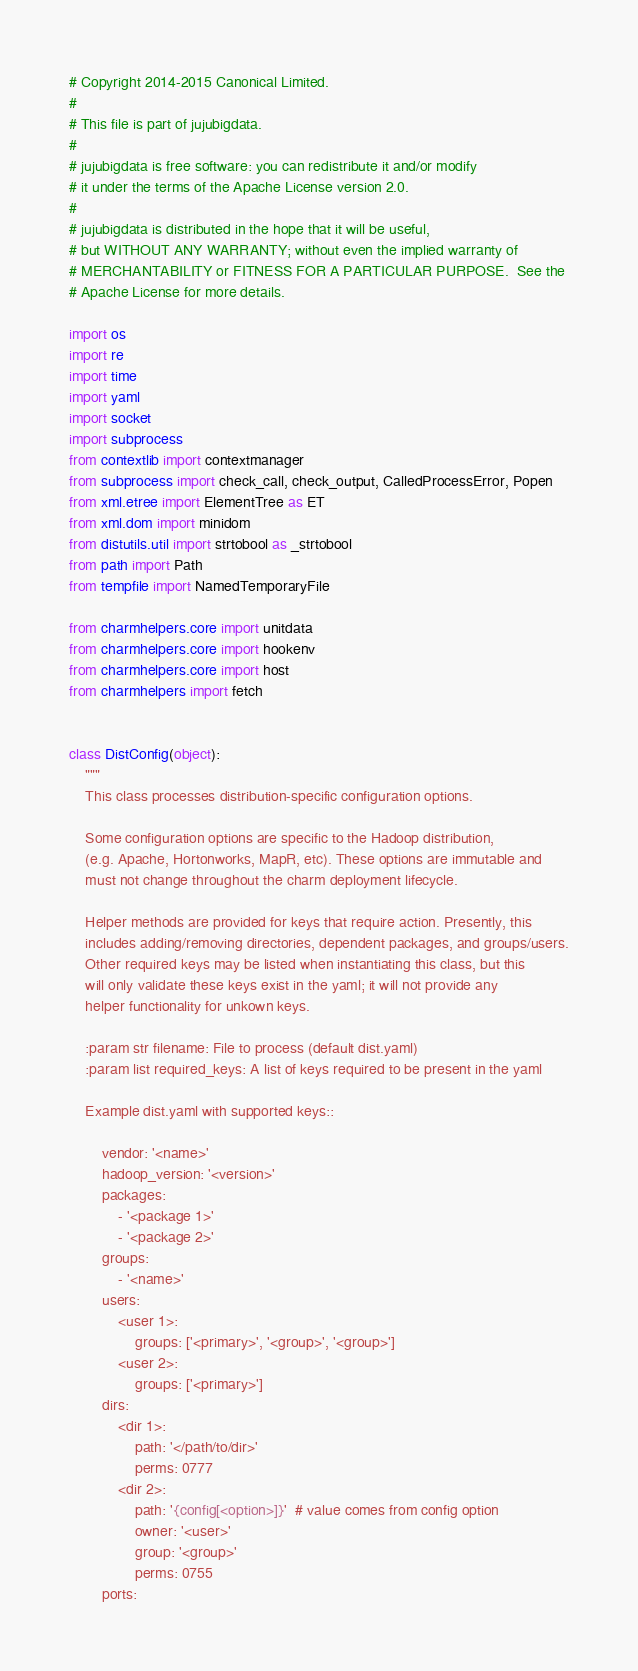Convert code to text. <code><loc_0><loc_0><loc_500><loc_500><_Python_># Copyright 2014-2015 Canonical Limited.
#
# This file is part of jujubigdata.
#
# jujubigdata is free software: you can redistribute it and/or modify
# it under the terms of the Apache License version 2.0.
#
# jujubigdata is distributed in the hope that it will be useful,
# but WITHOUT ANY WARRANTY; without even the implied warranty of
# MERCHANTABILITY or FITNESS FOR A PARTICULAR PURPOSE.  See the
# Apache License for more details.

import os
import re
import time
import yaml
import socket
import subprocess
from contextlib import contextmanager
from subprocess import check_call, check_output, CalledProcessError, Popen
from xml.etree import ElementTree as ET
from xml.dom import minidom
from distutils.util import strtobool as _strtobool
from path import Path
from tempfile import NamedTemporaryFile

from charmhelpers.core import unitdata
from charmhelpers.core import hookenv
from charmhelpers.core import host
from charmhelpers import fetch


class DistConfig(object):
    """
    This class processes distribution-specific configuration options.

    Some configuration options are specific to the Hadoop distribution,
    (e.g. Apache, Hortonworks, MapR, etc). These options are immutable and
    must not change throughout the charm deployment lifecycle.

    Helper methods are provided for keys that require action. Presently, this
    includes adding/removing directories, dependent packages, and groups/users.
    Other required keys may be listed when instantiating this class, but this
    will only validate these keys exist in the yaml; it will not provide any
    helper functionality for unkown keys.

    :param str filename: File to process (default dist.yaml)
    :param list required_keys: A list of keys required to be present in the yaml

    Example dist.yaml with supported keys::

        vendor: '<name>'
        hadoop_version: '<version>'
        packages:
            - '<package 1>'
            - '<package 2>'
        groups:
            - '<name>'
        users:
            <user 1>:
                groups: ['<primary>', '<group>', '<group>']
            <user 2>:
                groups: ['<primary>']
        dirs:
            <dir 1>:
                path: '</path/to/dir>'
                perms: 0777
            <dir 2>:
                path: '{config[<option>]}'  # value comes from config option
                owner: '<user>'
                group: '<group>'
                perms: 0755
        ports:</code> 